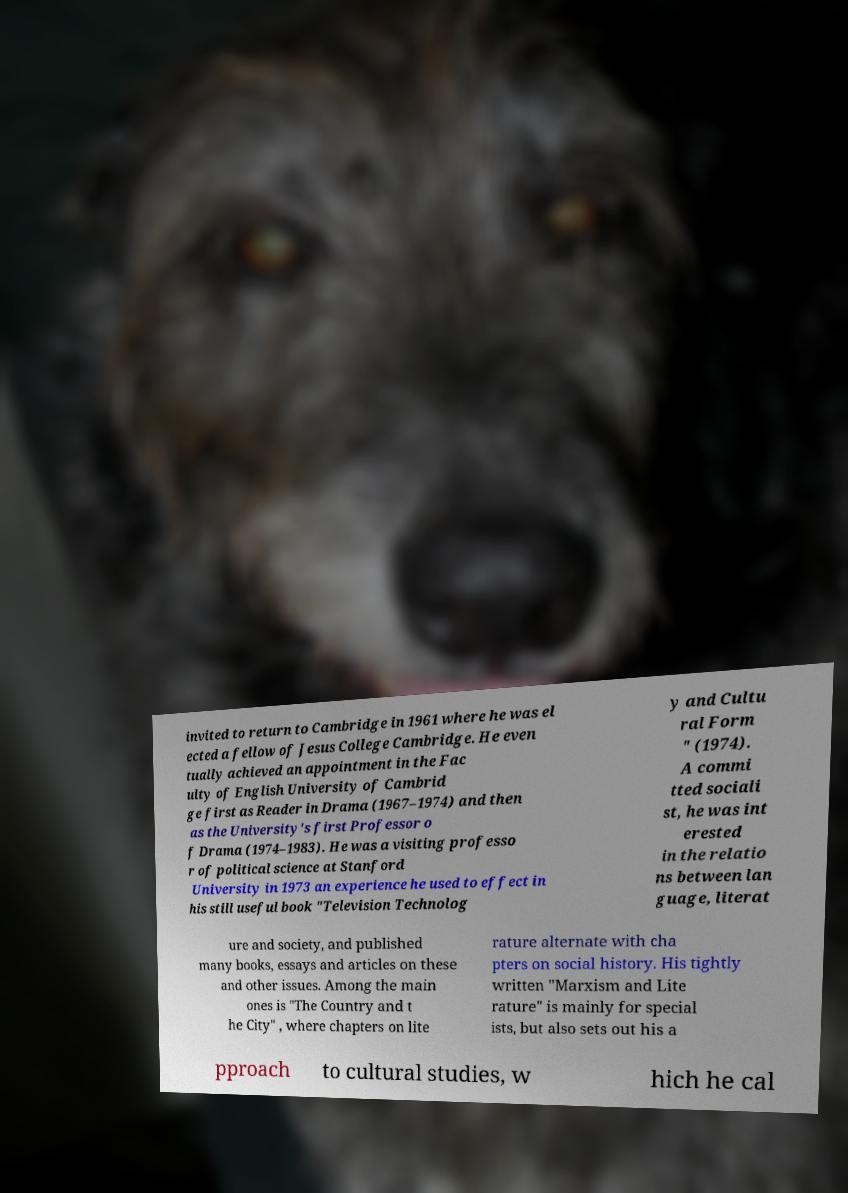What messages or text are displayed in this image? I need them in a readable, typed format. invited to return to Cambridge in 1961 where he was el ected a fellow of Jesus College Cambridge. He even tually achieved an appointment in the Fac ulty of English University of Cambrid ge first as Reader in Drama (1967–1974) and then as the University's first Professor o f Drama (1974–1983). He was a visiting professo r of political science at Stanford University in 1973 an experience he used to effect in his still useful book "Television Technolog y and Cultu ral Form " (1974). A commi tted sociali st, he was int erested in the relatio ns between lan guage, literat ure and society, and published many books, essays and articles on these and other issues. Among the main ones is "The Country and t he City" , where chapters on lite rature alternate with cha pters on social history. His tightly written "Marxism and Lite rature" is mainly for special ists, but also sets out his a pproach to cultural studies, w hich he cal 